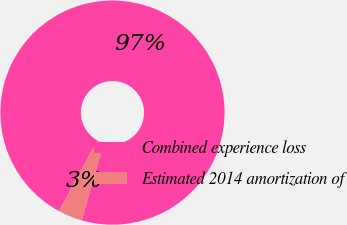<chart> <loc_0><loc_0><loc_500><loc_500><pie_chart><fcel>Combined experience loss<fcel>Estimated 2014 amortization of<nl><fcel>96.52%<fcel>3.48%<nl></chart> 